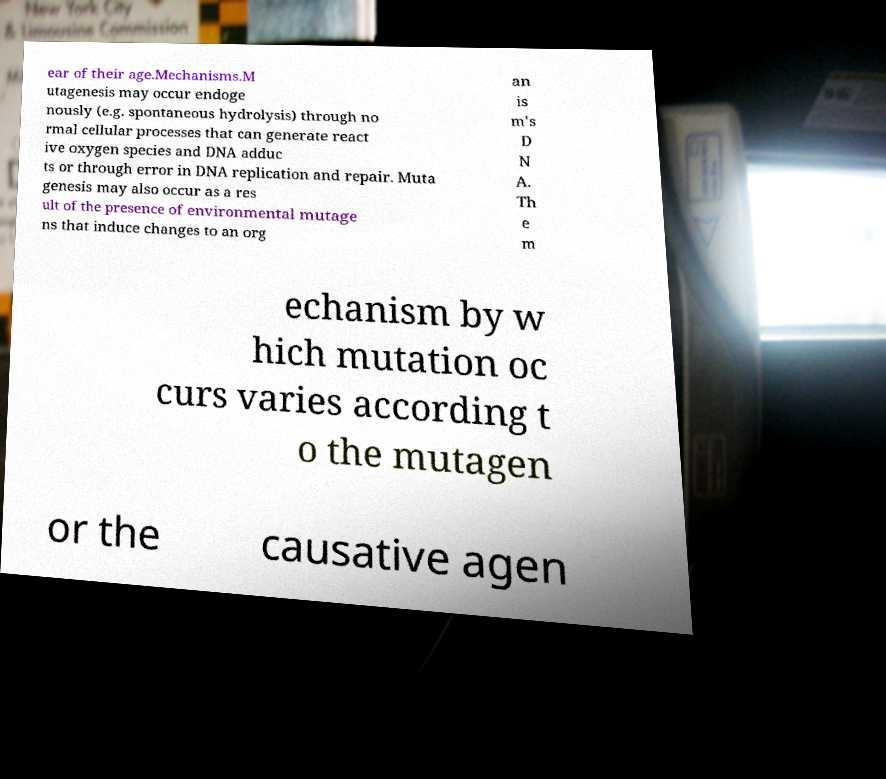What messages or text are displayed in this image? I need them in a readable, typed format. ear of their age.Mechanisms.M utagenesis may occur endoge nously (e.g. spontaneous hydrolysis) through no rmal cellular processes that can generate react ive oxygen species and DNA adduc ts or through error in DNA replication and repair. Muta genesis may also occur as a res ult of the presence of environmental mutage ns that induce changes to an org an is m's D N A. Th e m echanism by w hich mutation oc curs varies according t o the mutagen or the causative agen 